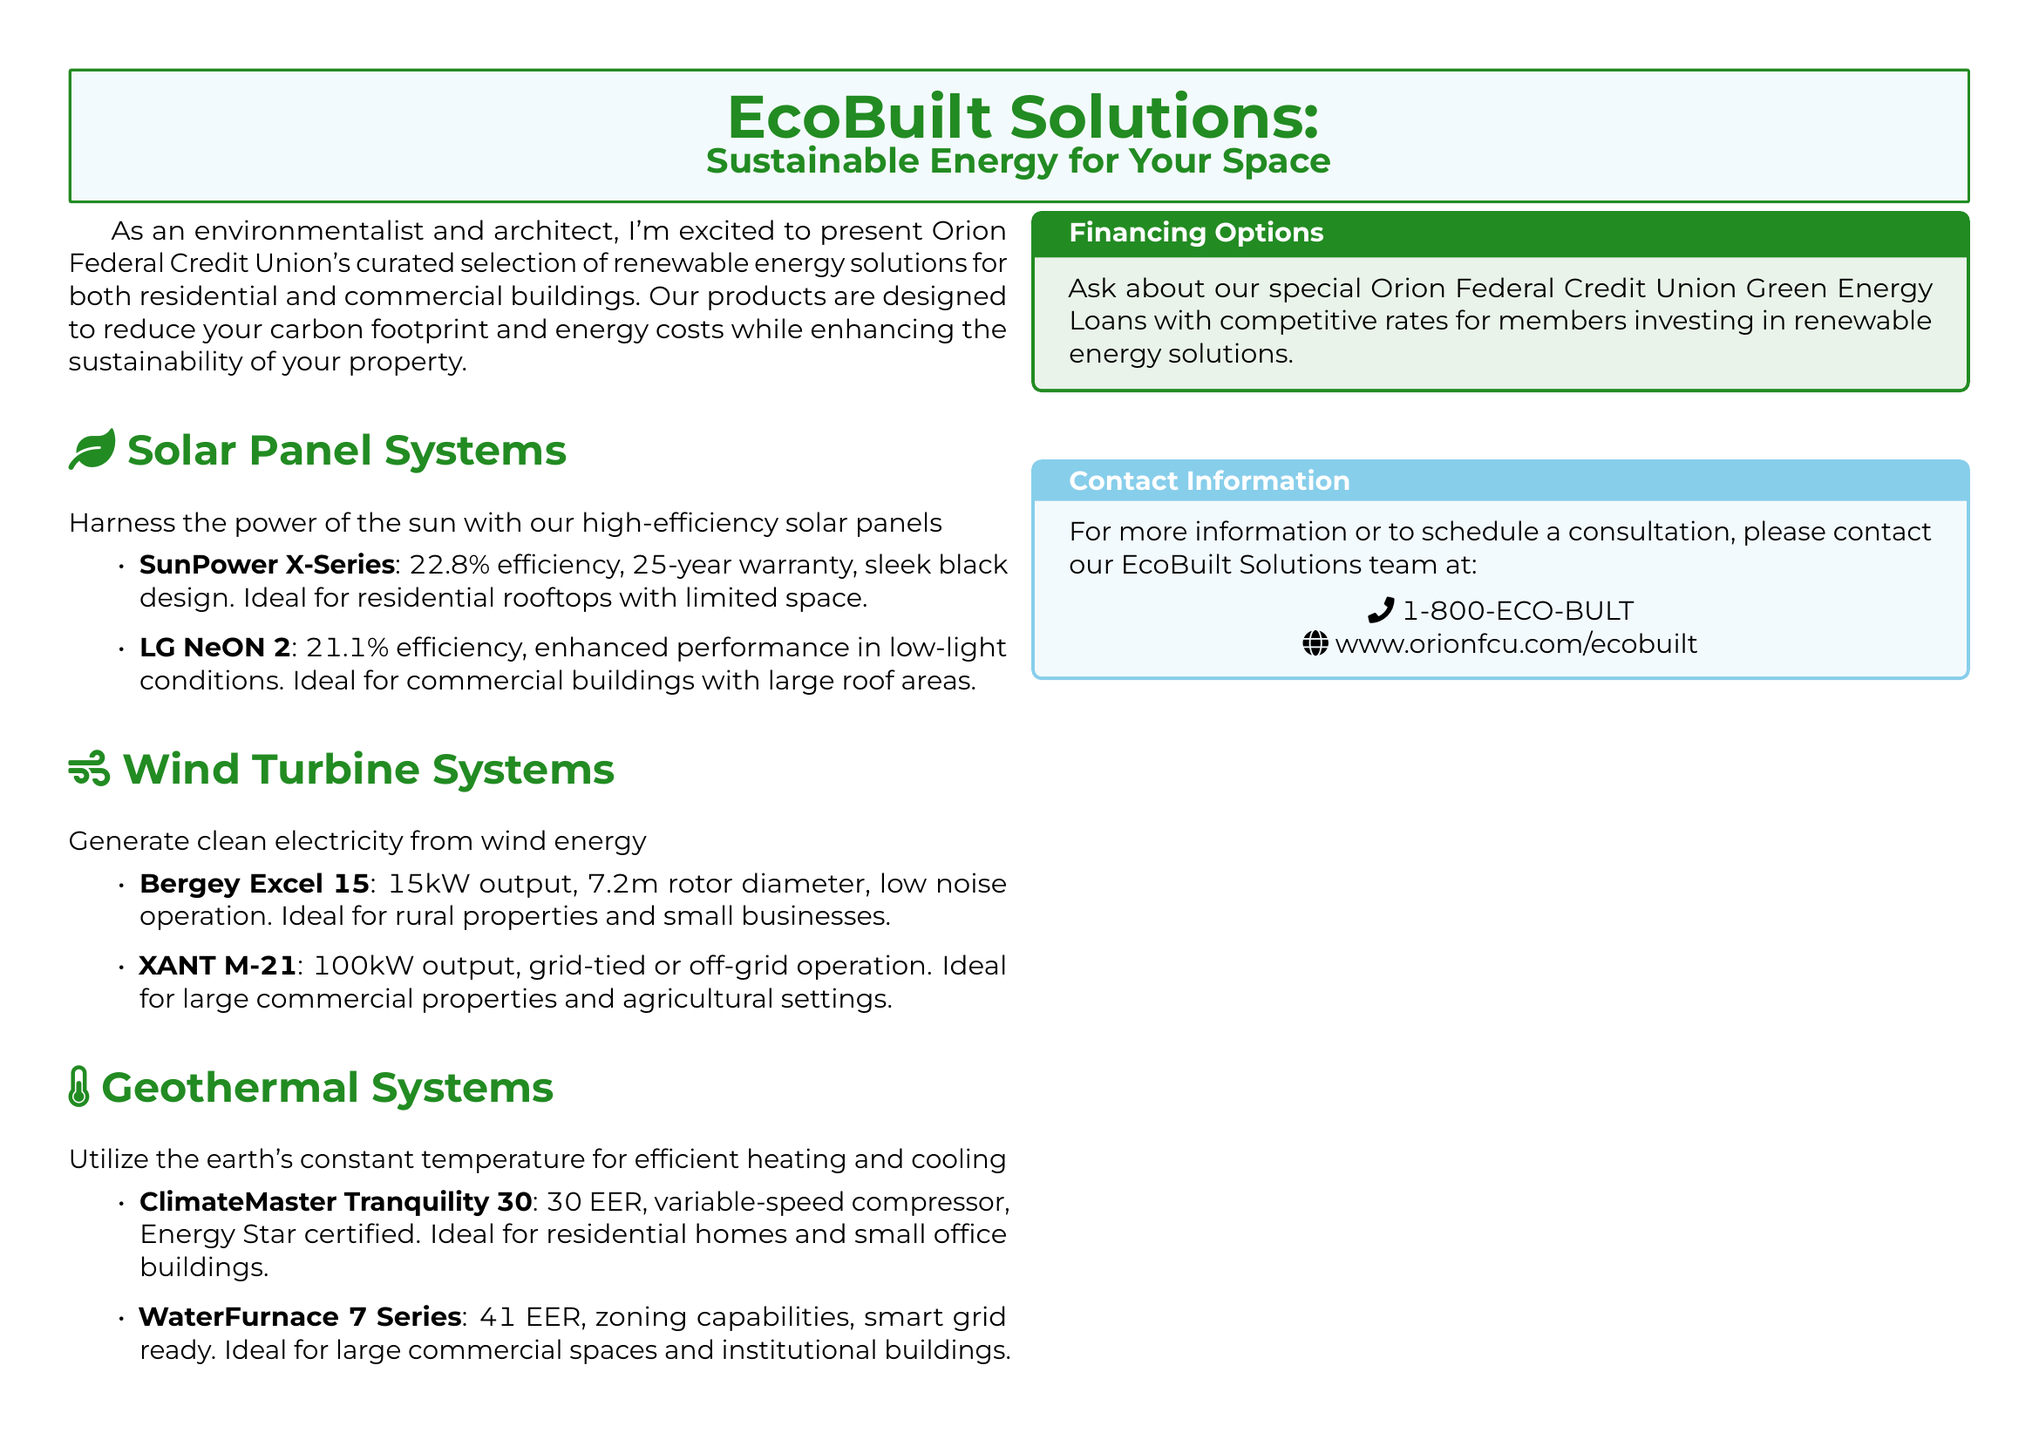What is the efficiency of the SunPower X-Series solar panel? The efficiency of the SunPower X-Series solar panel is listed in the document.
Answer: 22.8% What type of turbine is ideal for rural properties? The document specifies which wind turbine is suitable for rural properties.
Answer: Bergey Excel 15 What is the EER rating of the WaterFurnace 7 Series geothermal system? The EER rating of the WaterFurnace 7 Series geothermal system is mentioned in the document.
Answer: 41 Which product is designed for large commercial spaces? The document outlines which geothermal system is intended for large commercial spaces.
Answer: WaterFurnace 7 Series What is the warranty period for SunPower X-Series solar panels? The warranty period for SunPower X-Series solar panels is stated in the document.
Answer: 25-year What financing options are available for credit union members? The document mentions specific financing options for members investing in renewable energy solutions.
Answer: Green Energy Loans What is the rotor diameter of the XANT M-21 wind turbine? The rotor diameter of the XANT M-21 wind turbine is explicitly mentioned in the document.
Answer: Not specified What are the two main types of renewable energy solutions listed? The document categorizes the renewable energy solutions available.
Answer: Solar panels, wind turbines, geothermal systems Which solar panel is ideal for commercial buildings? The document indicates which solar panel works best for commercial buildings.
Answer: LG NeON 2 